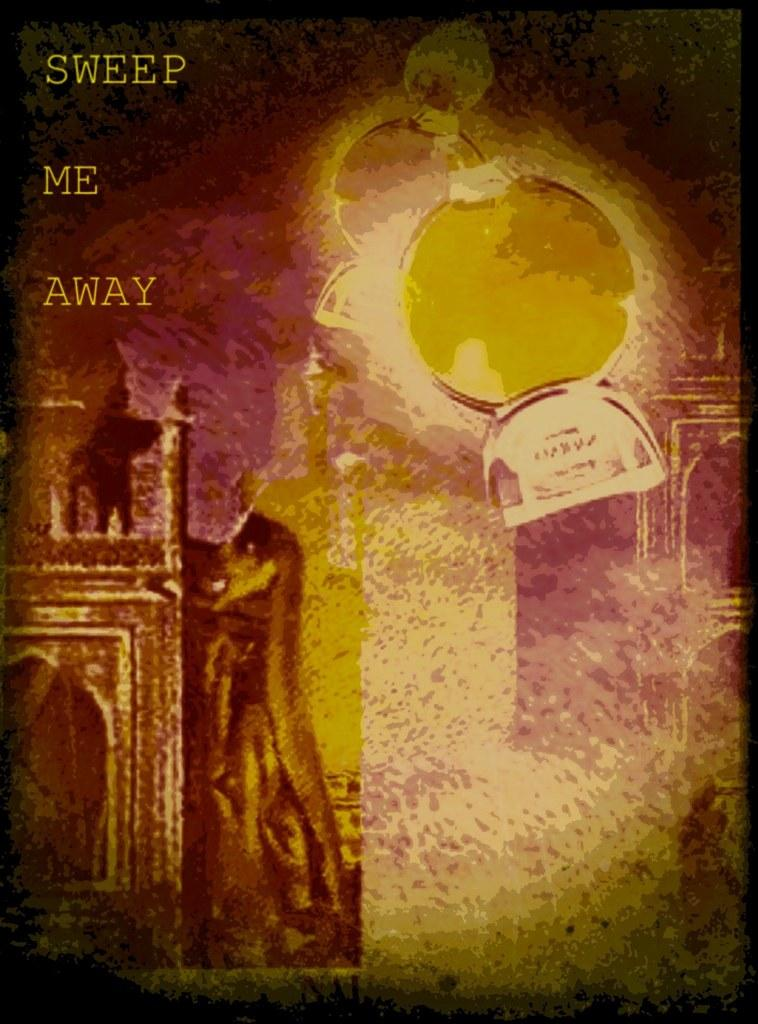<image>
Render a clear and concise summary of the photo. A blurry painting with the words sweep me away on it 